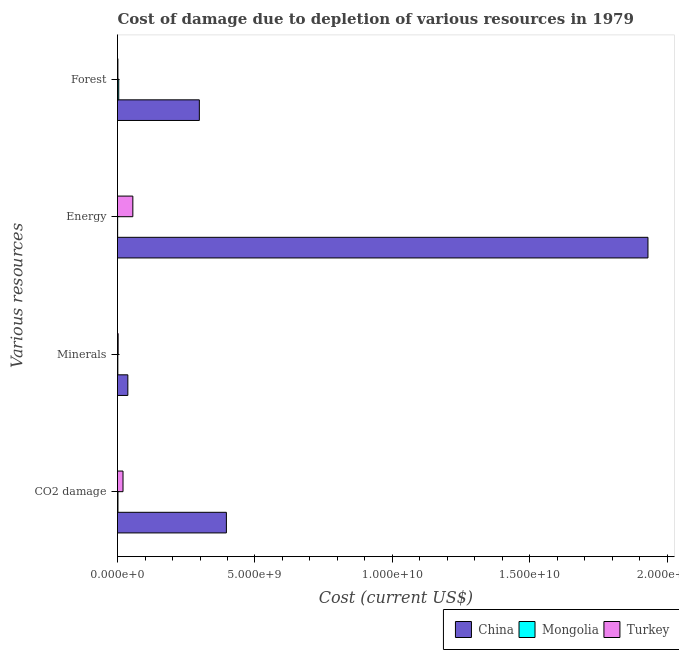How many groups of bars are there?
Provide a short and direct response. 4. How many bars are there on the 4th tick from the top?
Ensure brevity in your answer.  3. How many bars are there on the 2nd tick from the bottom?
Make the answer very short. 3. What is the label of the 1st group of bars from the top?
Keep it short and to the point. Forest. What is the cost of damage due to depletion of energy in Mongolia?
Provide a short and direct response. 4.81e+06. Across all countries, what is the maximum cost of damage due to depletion of forests?
Your response must be concise. 2.98e+09. Across all countries, what is the minimum cost of damage due to depletion of minerals?
Your response must be concise. 1.25e+07. In which country was the cost of damage due to depletion of minerals maximum?
Keep it short and to the point. China. In which country was the cost of damage due to depletion of minerals minimum?
Keep it short and to the point. Mongolia. What is the total cost of damage due to depletion of forests in the graph?
Offer a terse response. 3.04e+09. What is the difference between the cost of damage due to depletion of coal in Mongolia and that in China?
Your answer should be compact. -3.94e+09. What is the difference between the cost of damage due to depletion of energy in China and the cost of damage due to depletion of forests in Mongolia?
Your answer should be very brief. 1.92e+1. What is the average cost of damage due to depletion of forests per country?
Offer a very short reply. 1.01e+09. What is the difference between the cost of damage due to depletion of energy and cost of damage due to depletion of minerals in Mongolia?
Offer a terse response. -7.69e+06. What is the ratio of the cost of damage due to depletion of forests in China to that in Turkey?
Ensure brevity in your answer.  201.54. Is the cost of damage due to depletion of forests in Mongolia less than that in China?
Give a very brief answer. Yes. What is the difference between the highest and the second highest cost of damage due to depletion of forests?
Your answer should be very brief. 2.93e+09. What is the difference between the highest and the lowest cost of damage due to depletion of forests?
Make the answer very short. 2.96e+09. In how many countries, is the cost of damage due to depletion of minerals greater than the average cost of damage due to depletion of minerals taken over all countries?
Your answer should be compact. 1. Is the sum of the cost of damage due to depletion of minerals in Turkey and Mongolia greater than the maximum cost of damage due to depletion of coal across all countries?
Give a very brief answer. No. Is it the case that in every country, the sum of the cost of damage due to depletion of energy and cost of damage due to depletion of forests is greater than the sum of cost of damage due to depletion of coal and cost of damage due to depletion of minerals?
Keep it short and to the point. No. What does the 3rd bar from the top in Forest represents?
Offer a very short reply. China. What does the 2nd bar from the bottom in Energy represents?
Ensure brevity in your answer.  Mongolia. Are all the bars in the graph horizontal?
Your answer should be very brief. Yes. What is the difference between two consecutive major ticks on the X-axis?
Your answer should be compact. 5.00e+09. Are the values on the major ticks of X-axis written in scientific E-notation?
Provide a succinct answer. Yes. Does the graph contain any zero values?
Your answer should be very brief. No. Does the graph contain grids?
Provide a short and direct response. No. How many legend labels are there?
Your answer should be very brief. 3. What is the title of the graph?
Your answer should be very brief. Cost of damage due to depletion of various resources in 1979 . Does "Bulgaria" appear as one of the legend labels in the graph?
Your response must be concise. No. What is the label or title of the X-axis?
Provide a short and direct response. Cost (current US$). What is the label or title of the Y-axis?
Offer a very short reply. Various resources. What is the Cost (current US$) of China in CO2 damage?
Provide a succinct answer. 3.96e+09. What is the Cost (current US$) of Mongolia in CO2 damage?
Keep it short and to the point. 1.67e+07. What is the Cost (current US$) of Turkey in CO2 damage?
Keep it short and to the point. 2.00e+08. What is the Cost (current US$) of China in Minerals?
Offer a terse response. 3.76e+08. What is the Cost (current US$) in Mongolia in Minerals?
Your answer should be compact. 1.25e+07. What is the Cost (current US$) of Turkey in Minerals?
Keep it short and to the point. 2.35e+07. What is the Cost (current US$) in China in Energy?
Your answer should be compact. 1.93e+1. What is the Cost (current US$) in Mongolia in Energy?
Give a very brief answer. 4.81e+06. What is the Cost (current US$) in Turkey in Energy?
Your answer should be very brief. 5.58e+08. What is the Cost (current US$) of China in Forest?
Provide a short and direct response. 2.98e+09. What is the Cost (current US$) of Mongolia in Forest?
Provide a short and direct response. 4.47e+07. What is the Cost (current US$) of Turkey in Forest?
Your answer should be very brief. 1.48e+07. Across all Various resources, what is the maximum Cost (current US$) of China?
Provide a succinct answer. 1.93e+1. Across all Various resources, what is the maximum Cost (current US$) in Mongolia?
Keep it short and to the point. 4.47e+07. Across all Various resources, what is the maximum Cost (current US$) in Turkey?
Your answer should be very brief. 5.58e+08. Across all Various resources, what is the minimum Cost (current US$) in China?
Offer a very short reply. 3.76e+08. Across all Various resources, what is the minimum Cost (current US$) of Mongolia?
Keep it short and to the point. 4.81e+06. Across all Various resources, what is the minimum Cost (current US$) in Turkey?
Offer a very short reply. 1.48e+07. What is the total Cost (current US$) in China in the graph?
Provide a succinct answer. 2.66e+1. What is the total Cost (current US$) in Mongolia in the graph?
Make the answer very short. 7.87e+07. What is the total Cost (current US$) in Turkey in the graph?
Offer a terse response. 7.96e+08. What is the difference between the Cost (current US$) in China in CO2 damage and that in Minerals?
Provide a short and direct response. 3.58e+09. What is the difference between the Cost (current US$) in Mongolia in CO2 damage and that in Minerals?
Offer a very short reply. 4.18e+06. What is the difference between the Cost (current US$) of Turkey in CO2 damage and that in Minerals?
Ensure brevity in your answer.  1.77e+08. What is the difference between the Cost (current US$) of China in CO2 damage and that in Energy?
Your response must be concise. -1.53e+1. What is the difference between the Cost (current US$) of Mongolia in CO2 damage and that in Energy?
Make the answer very short. 1.19e+07. What is the difference between the Cost (current US$) in Turkey in CO2 damage and that in Energy?
Keep it short and to the point. -3.58e+08. What is the difference between the Cost (current US$) of China in CO2 damage and that in Forest?
Ensure brevity in your answer.  9.83e+08. What is the difference between the Cost (current US$) of Mongolia in CO2 damage and that in Forest?
Keep it short and to the point. -2.80e+07. What is the difference between the Cost (current US$) of Turkey in CO2 damage and that in Forest?
Your response must be concise. 1.85e+08. What is the difference between the Cost (current US$) of China in Minerals and that in Energy?
Provide a succinct answer. -1.89e+1. What is the difference between the Cost (current US$) in Mongolia in Minerals and that in Energy?
Your answer should be compact. 7.69e+06. What is the difference between the Cost (current US$) in Turkey in Minerals and that in Energy?
Your answer should be compact. -5.34e+08. What is the difference between the Cost (current US$) of China in Minerals and that in Forest?
Your answer should be very brief. -2.60e+09. What is the difference between the Cost (current US$) of Mongolia in Minerals and that in Forest?
Make the answer very short. -3.22e+07. What is the difference between the Cost (current US$) in Turkey in Minerals and that in Forest?
Your answer should be very brief. 8.75e+06. What is the difference between the Cost (current US$) of China in Energy and that in Forest?
Keep it short and to the point. 1.63e+1. What is the difference between the Cost (current US$) in Mongolia in Energy and that in Forest?
Keep it short and to the point. -3.99e+07. What is the difference between the Cost (current US$) in Turkey in Energy and that in Forest?
Make the answer very short. 5.43e+08. What is the difference between the Cost (current US$) of China in CO2 damage and the Cost (current US$) of Mongolia in Minerals?
Offer a terse response. 3.95e+09. What is the difference between the Cost (current US$) in China in CO2 damage and the Cost (current US$) in Turkey in Minerals?
Offer a terse response. 3.94e+09. What is the difference between the Cost (current US$) in Mongolia in CO2 damage and the Cost (current US$) in Turkey in Minerals?
Offer a very short reply. -6.83e+06. What is the difference between the Cost (current US$) in China in CO2 damage and the Cost (current US$) in Mongolia in Energy?
Provide a succinct answer. 3.96e+09. What is the difference between the Cost (current US$) of China in CO2 damage and the Cost (current US$) of Turkey in Energy?
Give a very brief answer. 3.40e+09. What is the difference between the Cost (current US$) in Mongolia in CO2 damage and the Cost (current US$) in Turkey in Energy?
Provide a short and direct response. -5.41e+08. What is the difference between the Cost (current US$) of China in CO2 damage and the Cost (current US$) of Mongolia in Forest?
Provide a succinct answer. 3.92e+09. What is the difference between the Cost (current US$) in China in CO2 damage and the Cost (current US$) in Turkey in Forest?
Provide a succinct answer. 3.95e+09. What is the difference between the Cost (current US$) of Mongolia in CO2 damage and the Cost (current US$) of Turkey in Forest?
Make the answer very short. 1.92e+06. What is the difference between the Cost (current US$) of China in Minerals and the Cost (current US$) of Mongolia in Energy?
Provide a succinct answer. 3.71e+08. What is the difference between the Cost (current US$) of China in Minerals and the Cost (current US$) of Turkey in Energy?
Give a very brief answer. -1.82e+08. What is the difference between the Cost (current US$) of Mongolia in Minerals and the Cost (current US$) of Turkey in Energy?
Give a very brief answer. -5.45e+08. What is the difference between the Cost (current US$) of China in Minerals and the Cost (current US$) of Mongolia in Forest?
Provide a short and direct response. 3.31e+08. What is the difference between the Cost (current US$) in China in Minerals and the Cost (current US$) in Turkey in Forest?
Provide a succinct answer. 3.61e+08. What is the difference between the Cost (current US$) of Mongolia in Minerals and the Cost (current US$) of Turkey in Forest?
Give a very brief answer. -2.26e+06. What is the difference between the Cost (current US$) in China in Energy and the Cost (current US$) in Mongolia in Forest?
Ensure brevity in your answer.  1.92e+1. What is the difference between the Cost (current US$) of China in Energy and the Cost (current US$) of Turkey in Forest?
Provide a succinct answer. 1.93e+1. What is the difference between the Cost (current US$) in Mongolia in Energy and the Cost (current US$) in Turkey in Forest?
Provide a succinct answer. -9.96e+06. What is the average Cost (current US$) of China per Various resources?
Make the answer very short. 6.65e+09. What is the average Cost (current US$) of Mongolia per Various resources?
Make the answer very short. 1.97e+07. What is the average Cost (current US$) of Turkey per Various resources?
Offer a very short reply. 1.99e+08. What is the difference between the Cost (current US$) of China and Cost (current US$) of Mongolia in CO2 damage?
Offer a terse response. 3.94e+09. What is the difference between the Cost (current US$) in China and Cost (current US$) in Turkey in CO2 damage?
Your response must be concise. 3.76e+09. What is the difference between the Cost (current US$) in Mongolia and Cost (current US$) in Turkey in CO2 damage?
Your answer should be very brief. -1.84e+08. What is the difference between the Cost (current US$) of China and Cost (current US$) of Mongolia in Minerals?
Give a very brief answer. 3.63e+08. What is the difference between the Cost (current US$) in China and Cost (current US$) in Turkey in Minerals?
Offer a very short reply. 3.52e+08. What is the difference between the Cost (current US$) of Mongolia and Cost (current US$) of Turkey in Minerals?
Make the answer very short. -1.10e+07. What is the difference between the Cost (current US$) of China and Cost (current US$) of Mongolia in Energy?
Offer a very short reply. 1.93e+1. What is the difference between the Cost (current US$) of China and Cost (current US$) of Turkey in Energy?
Offer a very short reply. 1.87e+1. What is the difference between the Cost (current US$) of Mongolia and Cost (current US$) of Turkey in Energy?
Give a very brief answer. -5.53e+08. What is the difference between the Cost (current US$) of China and Cost (current US$) of Mongolia in Forest?
Your answer should be very brief. 2.93e+09. What is the difference between the Cost (current US$) in China and Cost (current US$) in Turkey in Forest?
Offer a very short reply. 2.96e+09. What is the difference between the Cost (current US$) of Mongolia and Cost (current US$) of Turkey in Forest?
Keep it short and to the point. 2.99e+07. What is the ratio of the Cost (current US$) of China in CO2 damage to that in Minerals?
Offer a very short reply. 10.54. What is the ratio of the Cost (current US$) in Mongolia in CO2 damage to that in Minerals?
Offer a very short reply. 1.33. What is the ratio of the Cost (current US$) in Turkey in CO2 damage to that in Minerals?
Keep it short and to the point. 8.51. What is the ratio of the Cost (current US$) in China in CO2 damage to that in Energy?
Your answer should be very brief. 0.21. What is the ratio of the Cost (current US$) in Mongolia in CO2 damage to that in Energy?
Offer a terse response. 3.47. What is the ratio of the Cost (current US$) of Turkey in CO2 damage to that in Energy?
Your answer should be compact. 0.36. What is the ratio of the Cost (current US$) of China in CO2 damage to that in Forest?
Ensure brevity in your answer.  1.33. What is the ratio of the Cost (current US$) of Mongolia in CO2 damage to that in Forest?
Provide a short and direct response. 0.37. What is the ratio of the Cost (current US$) of Turkey in CO2 damage to that in Forest?
Offer a terse response. 13.56. What is the ratio of the Cost (current US$) in China in Minerals to that in Energy?
Offer a very short reply. 0.02. What is the ratio of the Cost (current US$) in Mongolia in Minerals to that in Energy?
Offer a terse response. 2.6. What is the ratio of the Cost (current US$) of Turkey in Minerals to that in Energy?
Make the answer very short. 0.04. What is the ratio of the Cost (current US$) in China in Minerals to that in Forest?
Offer a terse response. 0.13. What is the ratio of the Cost (current US$) in Mongolia in Minerals to that in Forest?
Your answer should be compact. 0.28. What is the ratio of the Cost (current US$) of Turkey in Minerals to that in Forest?
Provide a short and direct response. 1.59. What is the ratio of the Cost (current US$) in China in Energy to that in Forest?
Ensure brevity in your answer.  6.48. What is the ratio of the Cost (current US$) in Mongolia in Energy to that in Forest?
Offer a terse response. 0.11. What is the ratio of the Cost (current US$) of Turkey in Energy to that in Forest?
Your response must be concise. 37.76. What is the difference between the highest and the second highest Cost (current US$) of China?
Provide a short and direct response. 1.53e+1. What is the difference between the highest and the second highest Cost (current US$) of Mongolia?
Provide a short and direct response. 2.80e+07. What is the difference between the highest and the second highest Cost (current US$) of Turkey?
Provide a succinct answer. 3.58e+08. What is the difference between the highest and the lowest Cost (current US$) of China?
Keep it short and to the point. 1.89e+1. What is the difference between the highest and the lowest Cost (current US$) in Mongolia?
Your answer should be very brief. 3.99e+07. What is the difference between the highest and the lowest Cost (current US$) of Turkey?
Ensure brevity in your answer.  5.43e+08. 